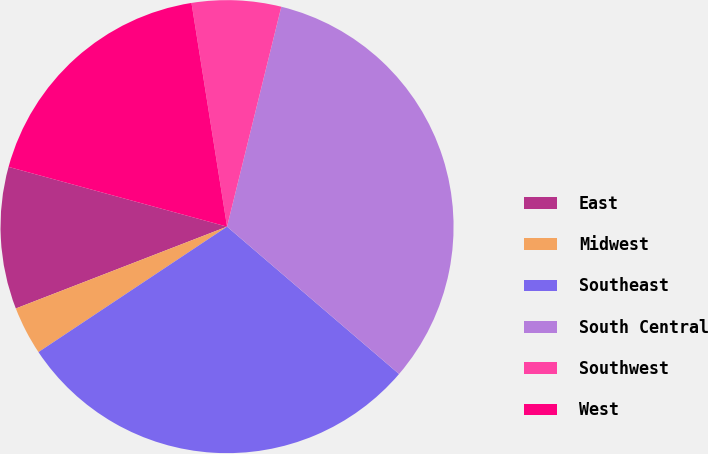Convert chart. <chart><loc_0><loc_0><loc_500><loc_500><pie_chart><fcel>East<fcel>Midwest<fcel>Southeast<fcel>South Central<fcel>Southwest<fcel>West<nl><fcel>10.13%<fcel>3.46%<fcel>29.38%<fcel>32.42%<fcel>6.36%<fcel>18.24%<nl></chart> 